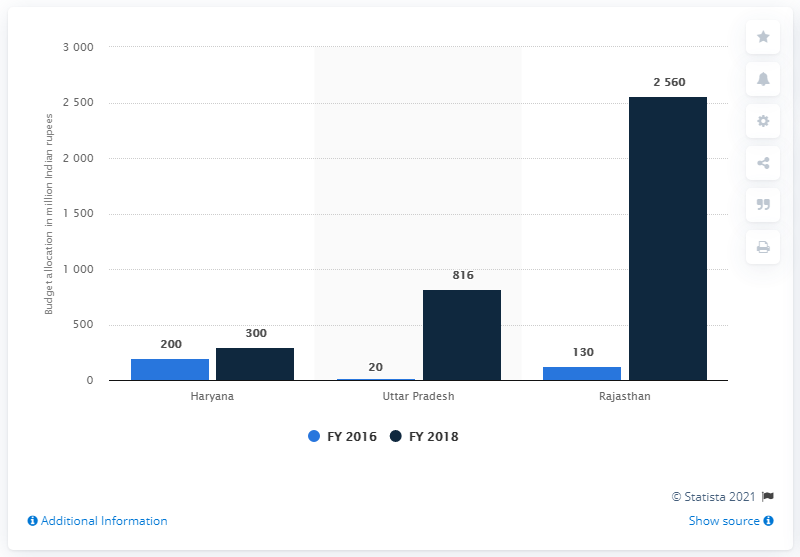Outline some significant characteristics in this image. In the fiscal year 2016, 130 rupees were allocated for the purpose of cow protection. 